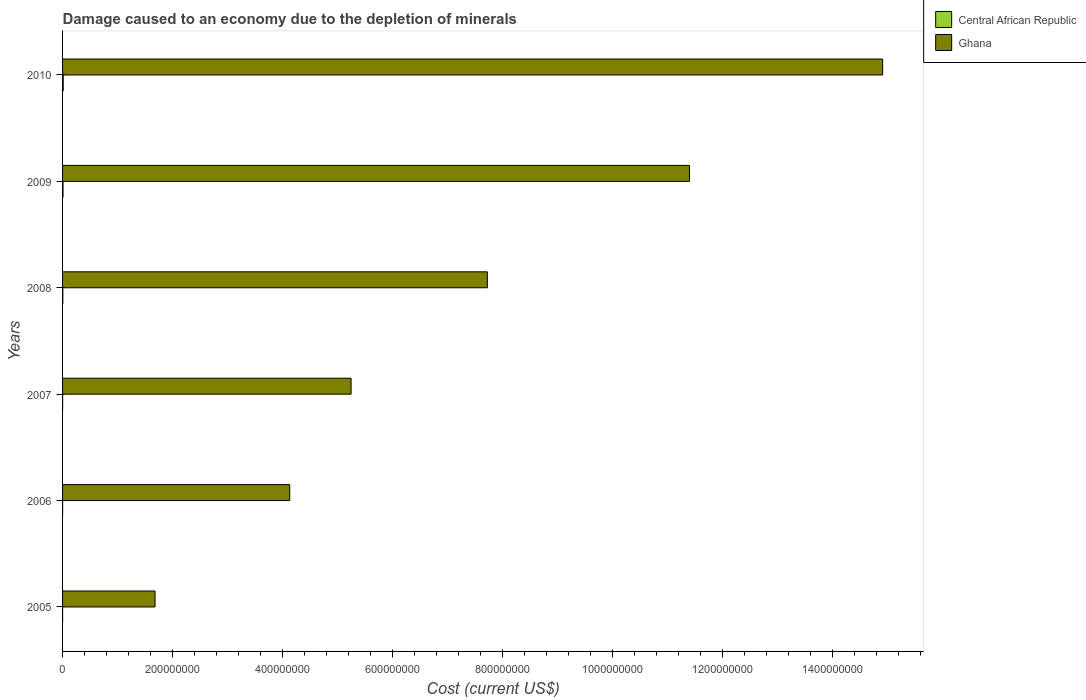How many different coloured bars are there?
Offer a very short reply. 2. How many groups of bars are there?
Your answer should be compact. 6. Are the number of bars per tick equal to the number of legend labels?
Give a very brief answer. Yes. Are the number of bars on each tick of the Y-axis equal?
Your answer should be compact. Yes. How many bars are there on the 2nd tick from the top?
Ensure brevity in your answer.  2. How many bars are there on the 6th tick from the bottom?
Keep it short and to the point. 2. What is the label of the 5th group of bars from the top?
Ensure brevity in your answer.  2006. What is the cost of damage caused due to the depletion of minerals in Ghana in 2006?
Offer a very short reply. 4.13e+08. Across all years, what is the maximum cost of damage caused due to the depletion of minerals in Ghana?
Offer a very short reply. 1.49e+09. Across all years, what is the minimum cost of damage caused due to the depletion of minerals in Central African Republic?
Your answer should be compact. 2.39e+04. In which year was the cost of damage caused due to the depletion of minerals in Central African Republic minimum?
Provide a succinct answer. 2005. What is the total cost of damage caused due to the depletion of minerals in Central African Republic in the graph?
Ensure brevity in your answer.  2.57e+06. What is the difference between the cost of damage caused due to the depletion of minerals in Ghana in 2007 and that in 2009?
Ensure brevity in your answer.  -6.15e+08. What is the difference between the cost of damage caused due to the depletion of minerals in Ghana in 2010 and the cost of damage caused due to the depletion of minerals in Central African Republic in 2007?
Ensure brevity in your answer.  1.49e+09. What is the average cost of damage caused due to the depletion of minerals in Ghana per year?
Offer a very short reply. 7.52e+08. In the year 2008, what is the difference between the cost of damage caused due to the depletion of minerals in Central African Republic and cost of damage caused due to the depletion of minerals in Ghana?
Provide a short and direct response. -7.72e+08. In how many years, is the cost of damage caused due to the depletion of minerals in Central African Republic greater than 1000000000 US$?
Your answer should be compact. 0. What is the ratio of the cost of damage caused due to the depletion of minerals in Ghana in 2005 to that in 2007?
Provide a succinct answer. 0.32. What is the difference between the highest and the second highest cost of damage caused due to the depletion of minerals in Ghana?
Your response must be concise. 3.51e+08. What is the difference between the highest and the lowest cost of damage caused due to the depletion of minerals in Ghana?
Your answer should be compact. 1.32e+09. In how many years, is the cost of damage caused due to the depletion of minerals in Central African Republic greater than the average cost of damage caused due to the depletion of minerals in Central African Republic taken over all years?
Keep it short and to the point. 3. What does the 2nd bar from the top in 2008 represents?
Provide a succinct answer. Central African Republic. What does the 1st bar from the bottom in 2006 represents?
Offer a terse response. Central African Republic. Are all the bars in the graph horizontal?
Ensure brevity in your answer.  Yes. Are the values on the major ticks of X-axis written in scientific E-notation?
Your answer should be very brief. No. Does the graph contain grids?
Your answer should be compact. No. Where does the legend appear in the graph?
Offer a terse response. Top right. How are the legend labels stacked?
Provide a short and direct response. Vertical. What is the title of the graph?
Provide a succinct answer. Damage caused to an economy due to the depletion of minerals. Does "Israel" appear as one of the legend labels in the graph?
Make the answer very short. No. What is the label or title of the X-axis?
Offer a very short reply. Cost (current US$). What is the Cost (current US$) in Central African Republic in 2005?
Offer a terse response. 2.39e+04. What is the Cost (current US$) of Ghana in 2005?
Provide a succinct answer. 1.68e+08. What is the Cost (current US$) in Central African Republic in 2006?
Provide a short and direct response. 3.76e+04. What is the Cost (current US$) in Ghana in 2006?
Give a very brief answer. 4.13e+08. What is the Cost (current US$) of Central African Republic in 2007?
Provide a succinct answer. 4.79e+04. What is the Cost (current US$) of Ghana in 2007?
Give a very brief answer. 5.25e+08. What is the Cost (current US$) in Central African Republic in 2008?
Provide a succinct answer. 4.46e+05. What is the Cost (current US$) in Ghana in 2008?
Make the answer very short. 7.72e+08. What is the Cost (current US$) of Central African Republic in 2009?
Provide a short and direct response. 8.25e+05. What is the Cost (current US$) of Ghana in 2009?
Make the answer very short. 1.14e+09. What is the Cost (current US$) in Central African Republic in 2010?
Offer a very short reply. 1.19e+06. What is the Cost (current US$) of Ghana in 2010?
Your response must be concise. 1.49e+09. Across all years, what is the maximum Cost (current US$) of Central African Republic?
Keep it short and to the point. 1.19e+06. Across all years, what is the maximum Cost (current US$) of Ghana?
Your response must be concise. 1.49e+09. Across all years, what is the minimum Cost (current US$) in Central African Republic?
Your response must be concise. 2.39e+04. Across all years, what is the minimum Cost (current US$) in Ghana?
Provide a short and direct response. 1.68e+08. What is the total Cost (current US$) in Central African Republic in the graph?
Make the answer very short. 2.57e+06. What is the total Cost (current US$) of Ghana in the graph?
Your response must be concise. 4.51e+09. What is the difference between the Cost (current US$) in Central African Republic in 2005 and that in 2006?
Make the answer very short. -1.37e+04. What is the difference between the Cost (current US$) in Ghana in 2005 and that in 2006?
Provide a succinct answer. -2.45e+08. What is the difference between the Cost (current US$) in Central African Republic in 2005 and that in 2007?
Ensure brevity in your answer.  -2.40e+04. What is the difference between the Cost (current US$) of Ghana in 2005 and that in 2007?
Keep it short and to the point. -3.56e+08. What is the difference between the Cost (current US$) in Central African Republic in 2005 and that in 2008?
Your response must be concise. -4.22e+05. What is the difference between the Cost (current US$) of Ghana in 2005 and that in 2008?
Provide a short and direct response. -6.04e+08. What is the difference between the Cost (current US$) in Central African Republic in 2005 and that in 2009?
Offer a very short reply. -8.01e+05. What is the difference between the Cost (current US$) of Ghana in 2005 and that in 2009?
Ensure brevity in your answer.  -9.72e+08. What is the difference between the Cost (current US$) in Central African Republic in 2005 and that in 2010?
Provide a short and direct response. -1.17e+06. What is the difference between the Cost (current US$) in Ghana in 2005 and that in 2010?
Offer a terse response. -1.32e+09. What is the difference between the Cost (current US$) in Central African Republic in 2006 and that in 2007?
Offer a very short reply. -1.03e+04. What is the difference between the Cost (current US$) in Ghana in 2006 and that in 2007?
Ensure brevity in your answer.  -1.12e+08. What is the difference between the Cost (current US$) of Central African Republic in 2006 and that in 2008?
Provide a short and direct response. -4.08e+05. What is the difference between the Cost (current US$) in Ghana in 2006 and that in 2008?
Ensure brevity in your answer.  -3.59e+08. What is the difference between the Cost (current US$) in Central African Republic in 2006 and that in 2009?
Offer a terse response. -7.87e+05. What is the difference between the Cost (current US$) in Ghana in 2006 and that in 2009?
Your answer should be very brief. -7.27e+08. What is the difference between the Cost (current US$) of Central African Republic in 2006 and that in 2010?
Your answer should be very brief. -1.15e+06. What is the difference between the Cost (current US$) in Ghana in 2006 and that in 2010?
Give a very brief answer. -1.08e+09. What is the difference between the Cost (current US$) of Central African Republic in 2007 and that in 2008?
Offer a terse response. -3.98e+05. What is the difference between the Cost (current US$) in Ghana in 2007 and that in 2008?
Your answer should be compact. -2.48e+08. What is the difference between the Cost (current US$) of Central African Republic in 2007 and that in 2009?
Offer a very short reply. -7.77e+05. What is the difference between the Cost (current US$) in Ghana in 2007 and that in 2009?
Make the answer very short. -6.15e+08. What is the difference between the Cost (current US$) of Central African Republic in 2007 and that in 2010?
Make the answer very short. -1.14e+06. What is the difference between the Cost (current US$) of Ghana in 2007 and that in 2010?
Your answer should be compact. -9.67e+08. What is the difference between the Cost (current US$) of Central African Republic in 2008 and that in 2009?
Make the answer very short. -3.79e+05. What is the difference between the Cost (current US$) of Ghana in 2008 and that in 2009?
Your answer should be very brief. -3.68e+08. What is the difference between the Cost (current US$) in Central African Republic in 2008 and that in 2010?
Provide a succinct answer. -7.45e+05. What is the difference between the Cost (current US$) in Ghana in 2008 and that in 2010?
Your answer should be compact. -7.19e+08. What is the difference between the Cost (current US$) of Central African Republic in 2009 and that in 2010?
Ensure brevity in your answer.  -3.65e+05. What is the difference between the Cost (current US$) in Ghana in 2009 and that in 2010?
Keep it short and to the point. -3.51e+08. What is the difference between the Cost (current US$) in Central African Republic in 2005 and the Cost (current US$) in Ghana in 2006?
Your answer should be compact. -4.13e+08. What is the difference between the Cost (current US$) in Central African Republic in 2005 and the Cost (current US$) in Ghana in 2007?
Your response must be concise. -5.25e+08. What is the difference between the Cost (current US$) in Central African Republic in 2005 and the Cost (current US$) in Ghana in 2008?
Ensure brevity in your answer.  -7.72e+08. What is the difference between the Cost (current US$) of Central African Republic in 2005 and the Cost (current US$) of Ghana in 2009?
Keep it short and to the point. -1.14e+09. What is the difference between the Cost (current US$) in Central African Republic in 2005 and the Cost (current US$) in Ghana in 2010?
Provide a short and direct response. -1.49e+09. What is the difference between the Cost (current US$) in Central African Republic in 2006 and the Cost (current US$) in Ghana in 2007?
Your response must be concise. -5.25e+08. What is the difference between the Cost (current US$) in Central African Republic in 2006 and the Cost (current US$) in Ghana in 2008?
Offer a terse response. -7.72e+08. What is the difference between the Cost (current US$) of Central African Republic in 2006 and the Cost (current US$) of Ghana in 2009?
Provide a succinct answer. -1.14e+09. What is the difference between the Cost (current US$) of Central African Republic in 2006 and the Cost (current US$) of Ghana in 2010?
Provide a succinct answer. -1.49e+09. What is the difference between the Cost (current US$) of Central African Republic in 2007 and the Cost (current US$) of Ghana in 2008?
Ensure brevity in your answer.  -7.72e+08. What is the difference between the Cost (current US$) of Central African Republic in 2007 and the Cost (current US$) of Ghana in 2009?
Ensure brevity in your answer.  -1.14e+09. What is the difference between the Cost (current US$) in Central African Republic in 2007 and the Cost (current US$) in Ghana in 2010?
Your answer should be very brief. -1.49e+09. What is the difference between the Cost (current US$) of Central African Republic in 2008 and the Cost (current US$) of Ghana in 2009?
Give a very brief answer. -1.14e+09. What is the difference between the Cost (current US$) of Central African Republic in 2008 and the Cost (current US$) of Ghana in 2010?
Offer a very short reply. -1.49e+09. What is the difference between the Cost (current US$) of Central African Republic in 2009 and the Cost (current US$) of Ghana in 2010?
Offer a terse response. -1.49e+09. What is the average Cost (current US$) of Central African Republic per year?
Offer a very short reply. 4.28e+05. What is the average Cost (current US$) of Ghana per year?
Provide a short and direct response. 7.52e+08. In the year 2005, what is the difference between the Cost (current US$) in Central African Republic and Cost (current US$) in Ghana?
Provide a succinct answer. -1.68e+08. In the year 2006, what is the difference between the Cost (current US$) of Central African Republic and Cost (current US$) of Ghana?
Keep it short and to the point. -4.13e+08. In the year 2007, what is the difference between the Cost (current US$) in Central African Republic and Cost (current US$) in Ghana?
Keep it short and to the point. -5.25e+08. In the year 2008, what is the difference between the Cost (current US$) of Central African Republic and Cost (current US$) of Ghana?
Provide a short and direct response. -7.72e+08. In the year 2009, what is the difference between the Cost (current US$) of Central African Republic and Cost (current US$) of Ghana?
Provide a short and direct response. -1.14e+09. In the year 2010, what is the difference between the Cost (current US$) of Central African Republic and Cost (current US$) of Ghana?
Give a very brief answer. -1.49e+09. What is the ratio of the Cost (current US$) in Central African Republic in 2005 to that in 2006?
Your response must be concise. 0.63. What is the ratio of the Cost (current US$) of Ghana in 2005 to that in 2006?
Ensure brevity in your answer.  0.41. What is the ratio of the Cost (current US$) of Central African Republic in 2005 to that in 2007?
Give a very brief answer. 0.5. What is the ratio of the Cost (current US$) in Ghana in 2005 to that in 2007?
Keep it short and to the point. 0.32. What is the ratio of the Cost (current US$) of Central African Republic in 2005 to that in 2008?
Your answer should be very brief. 0.05. What is the ratio of the Cost (current US$) of Ghana in 2005 to that in 2008?
Your response must be concise. 0.22. What is the ratio of the Cost (current US$) in Central African Republic in 2005 to that in 2009?
Your answer should be compact. 0.03. What is the ratio of the Cost (current US$) of Ghana in 2005 to that in 2009?
Provide a short and direct response. 0.15. What is the ratio of the Cost (current US$) in Central African Republic in 2005 to that in 2010?
Provide a short and direct response. 0.02. What is the ratio of the Cost (current US$) of Ghana in 2005 to that in 2010?
Your answer should be compact. 0.11. What is the ratio of the Cost (current US$) of Central African Republic in 2006 to that in 2007?
Ensure brevity in your answer.  0.79. What is the ratio of the Cost (current US$) of Ghana in 2006 to that in 2007?
Make the answer very short. 0.79. What is the ratio of the Cost (current US$) of Central African Republic in 2006 to that in 2008?
Offer a terse response. 0.08. What is the ratio of the Cost (current US$) in Ghana in 2006 to that in 2008?
Your answer should be compact. 0.53. What is the ratio of the Cost (current US$) in Central African Republic in 2006 to that in 2009?
Your answer should be compact. 0.05. What is the ratio of the Cost (current US$) of Ghana in 2006 to that in 2009?
Offer a terse response. 0.36. What is the ratio of the Cost (current US$) of Central African Republic in 2006 to that in 2010?
Offer a very short reply. 0.03. What is the ratio of the Cost (current US$) in Ghana in 2006 to that in 2010?
Offer a terse response. 0.28. What is the ratio of the Cost (current US$) of Central African Republic in 2007 to that in 2008?
Provide a succinct answer. 0.11. What is the ratio of the Cost (current US$) of Ghana in 2007 to that in 2008?
Keep it short and to the point. 0.68. What is the ratio of the Cost (current US$) of Central African Republic in 2007 to that in 2009?
Keep it short and to the point. 0.06. What is the ratio of the Cost (current US$) of Ghana in 2007 to that in 2009?
Offer a terse response. 0.46. What is the ratio of the Cost (current US$) of Central African Republic in 2007 to that in 2010?
Offer a terse response. 0.04. What is the ratio of the Cost (current US$) in Ghana in 2007 to that in 2010?
Offer a terse response. 0.35. What is the ratio of the Cost (current US$) of Central African Republic in 2008 to that in 2009?
Keep it short and to the point. 0.54. What is the ratio of the Cost (current US$) in Ghana in 2008 to that in 2009?
Keep it short and to the point. 0.68. What is the ratio of the Cost (current US$) in Central African Republic in 2008 to that in 2010?
Keep it short and to the point. 0.37. What is the ratio of the Cost (current US$) in Ghana in 2008 to that in 2010?
Offer a very short reply. 0.52. What is the ratio of the Cost (current US$) of Central African Republic in 2009 to that in 2010?
Your answer should be compact. 0.69. What is the ratio of the Cost (current US$) in Ghana in 2009 to that in 2010?
Offer a terse response. 0.76. What is the difference between the highest and the second highest Cost (current US$) in Central African Republic?
Your response must be concise. 3.65e+05. What is the difference between the highest and the second highest Cost (current US$) in Ghana?
Give a very brief answer. 3.51e+08. What is the difference between the highest and the lowest Cost (current US$) in Central African Republic?
Offer a terse response. 1.17e+06. What is the difference between the highest and the lowest Cost (current US$) in Ghana?
Your response must be concise. 1.32e+09. 